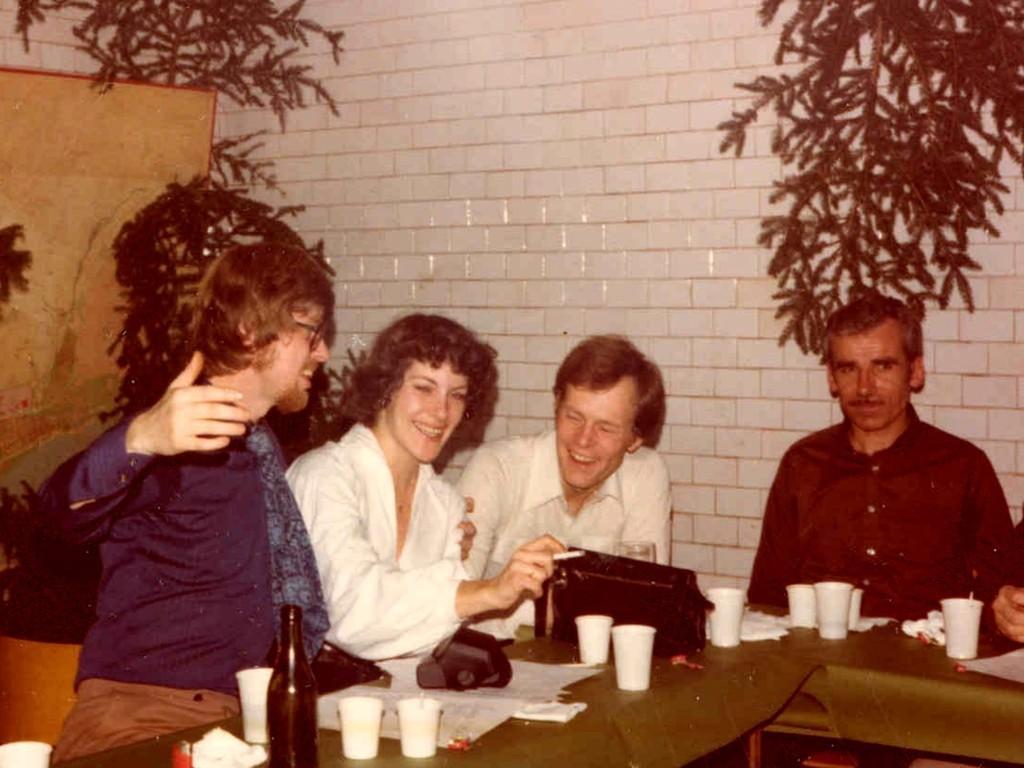Can you describe this image briefly? On the background we can see a wall with white colour stones. We can see plants here. We can see few persons sitting on chairs in front of a table and they all hold a smile on their faces and on the table we can see white colour glasses, papers, bottle. 